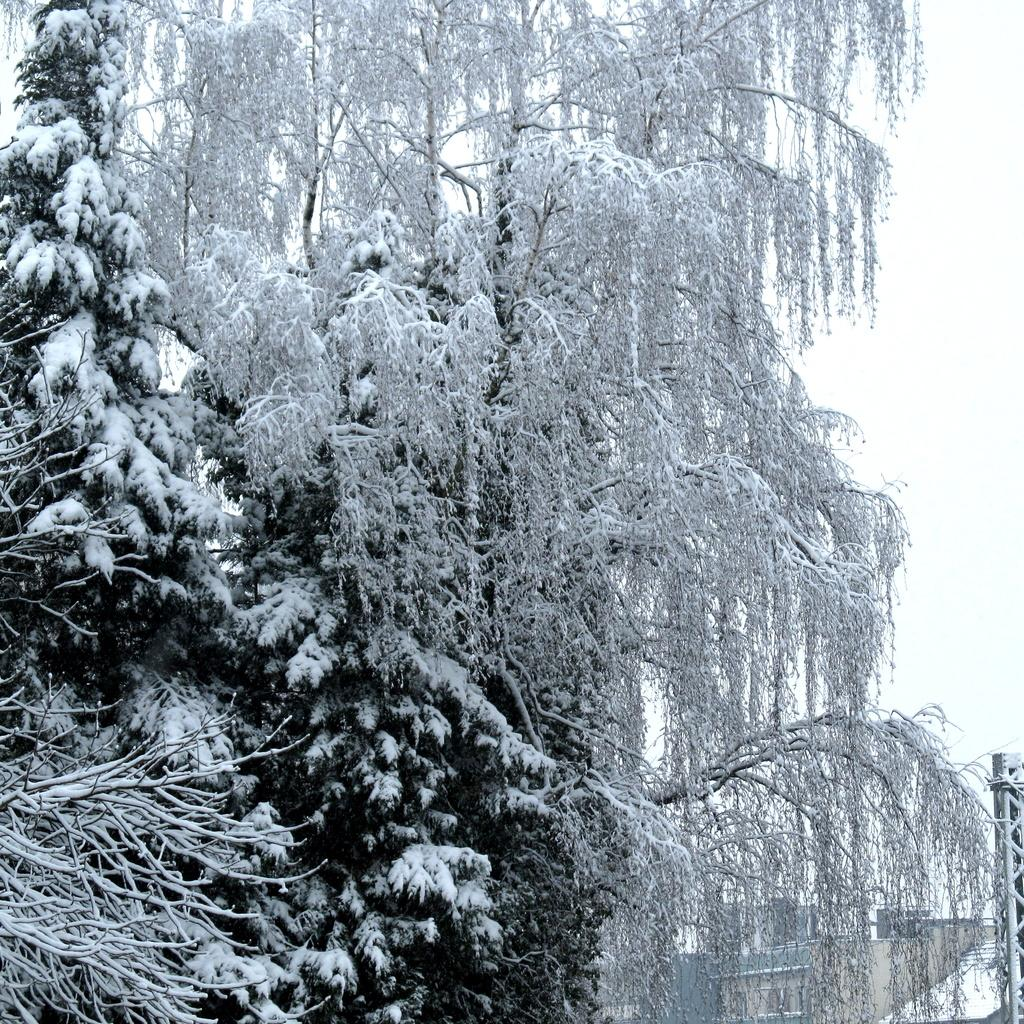What type of vegetation can be seen in the image? There are trees in the image. What is covering the trees in the image? There is snow on the trees in the image. How many quinces are hanging from the trees in the image? There are no quinces present in the image, as it only features trees covered in snow. 